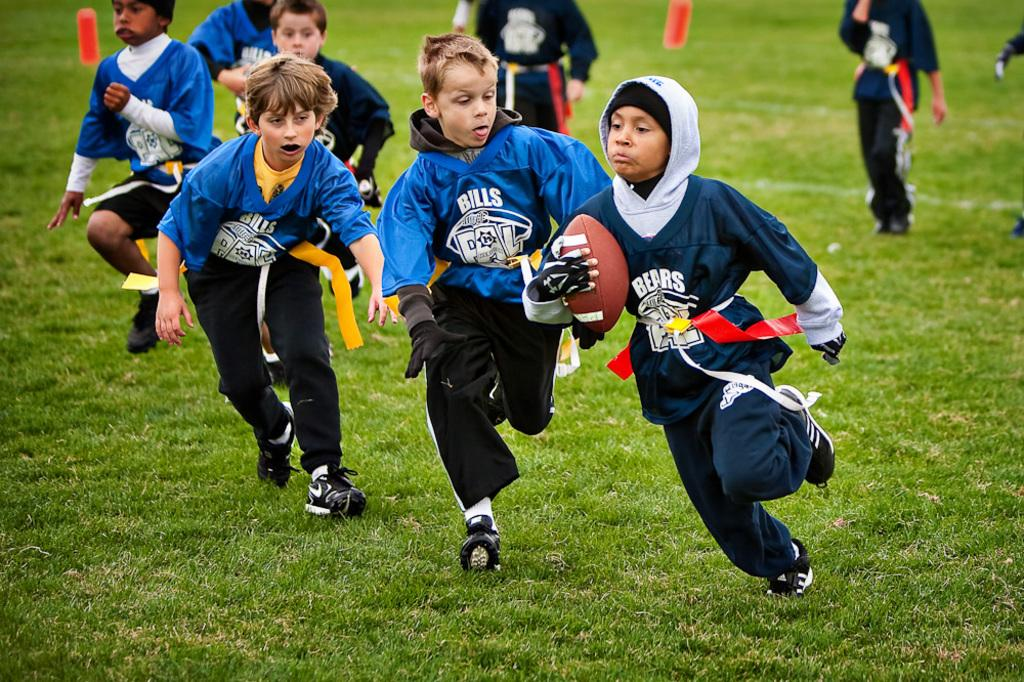<image>
Summarize the visual content of the image. Two young boys playing flag football for the Bills are chasing another young boy, with the football that plays for the Bears. 